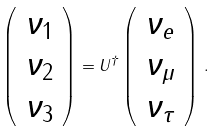Convert formula to latex. <formula><loc_0><loc_0><loc_500><loc_500>\left ( \begin{array} { l } \nu _ { 1 } \\ \nu _ { 2 } \\ \nu _ { 3 } \end{array} \right ) = U ^ { \dagger } \left ( \begin{array} { l } \nu _ { e } \\ \nu _ { \mu } \\ \nu _ { \tau } \end{array} \right ) \, .</formula> 